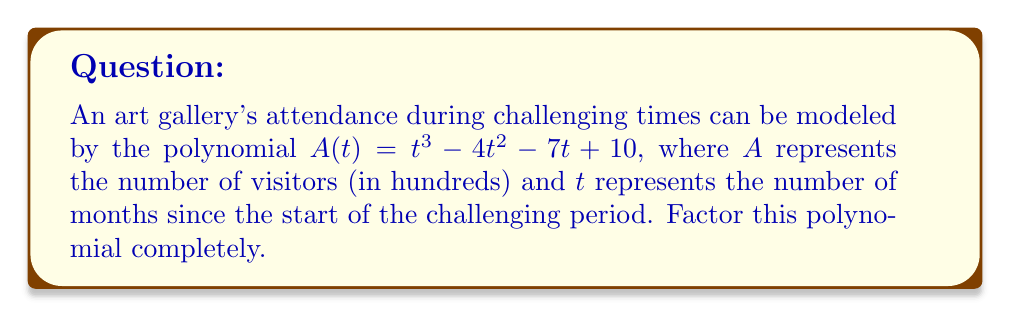Solve this math problem. Let's approach this step-by-step:

1) First, we need to check if there are any rational roots. We can use the rational root theorem. The possible rational roots are the factors of the constant term (10): ±1, ±2, ±5, ±10.

2) Testing these values, we find that $t = 1$ is a root of the polynomial.

3) We can factor out $(t - 1)$:

   $A(t) = (t - 1)(t^2 + at + b)$

4) To find $a$ and $b$, we can expand this and compare coefficients with the original polynomial:

   $(t - 1)(t^2 + at + b) = t^3 + at^2 + bt - t^2 - at - b$
                           $= t^3 + (a-1)t^2 + (b-a)t - b$

5) Comparing coefficients:

   $a - 1 = -4$, so $a = -3$
   $b - a = -7$, so $b = -10$

6) Our factored polynomial is now:

   $A(t) = (t - 1)(t^2 - 3t - 10)$

7) The quadratic factor can be further factored:

   $t^2 - 3t - 10 = (t - 5)(t + 2)$

8) Therefore, the final factored form is:

   $A(t) = (t - 1)(t - 5)(t + 2)$

This factorization represents the polynomial in terms of its roots, which are 1, 5, and -2.
Answer: $(t - 1)(t - 5)(t + 2)$ 